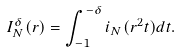<formula> <loc_0><loc_0><loc_500><loc_500>I _ { N } ^ { \delta } ( r ) = \int _ { - 1 } ^ { - \delta } i _ { N } ( r ^ { 2 } t ) d t .</formula> 